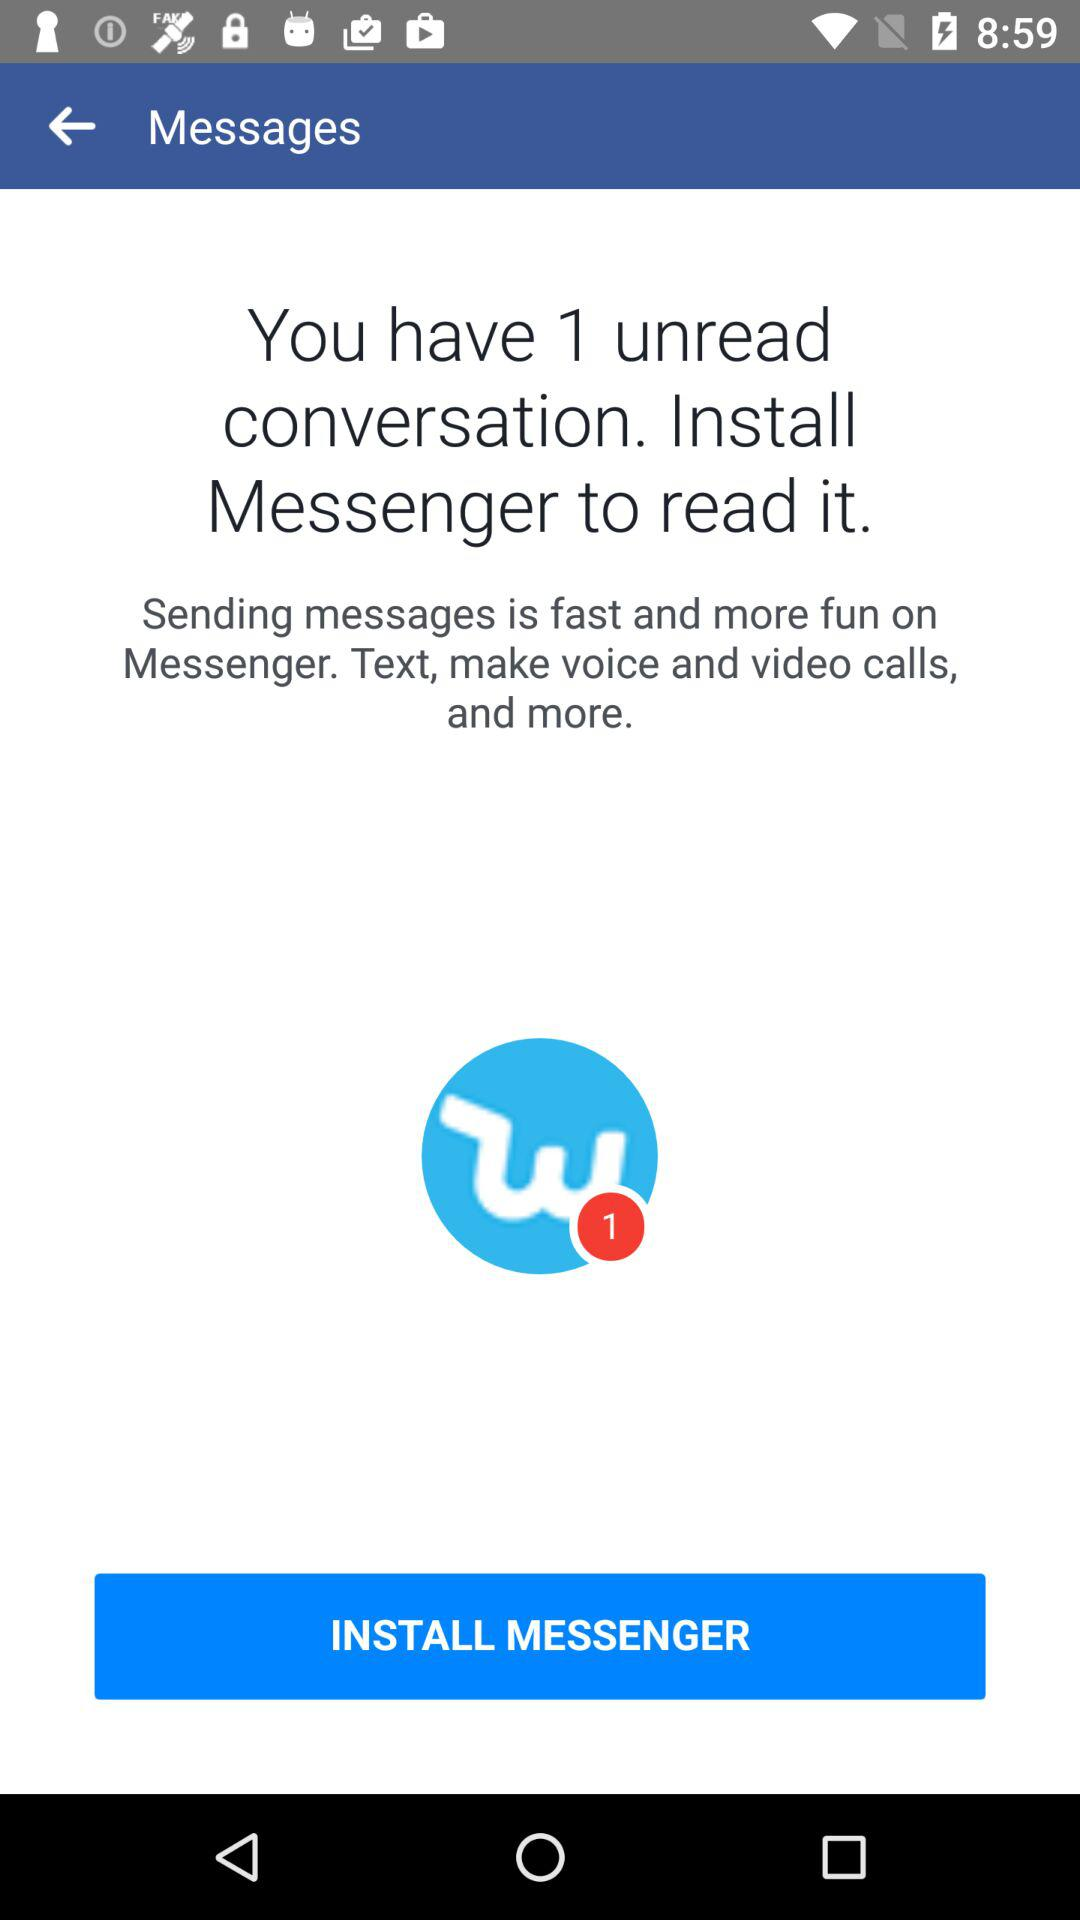How many more unread messages do I have than installed apps?
Answer the question using a single word or phrase. 1 